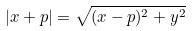Convert formula to latex. <formula><loc_0><loc_0><loc_500><loc_500>| x + p | = \sqrt { ( x - p ) ^ { 2 } + y ^ { 2 } }</formula> 